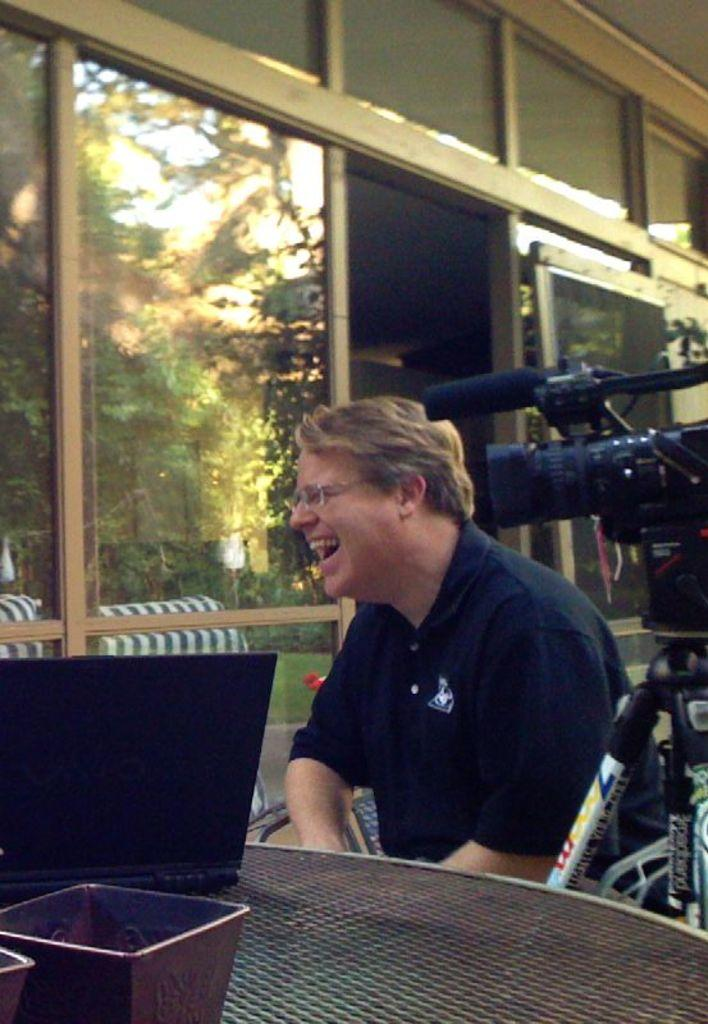What is the person in the image doing? The person is sitting on a chair and smiling. What can be seen on the person's face? The person is wearing spectacles. What is on the table in the image? There is a laptop and a bowl on the table. What other object is present in the image? There is a camera in the image. What can be seen in the background of the image? There are glasses and trees in the background. What thought is the person having about the impulse in the image? There is no indication of any thoughts or impulses in the image; it simply shows a person sitting on a chair, smiling, and wearing spectacles. 